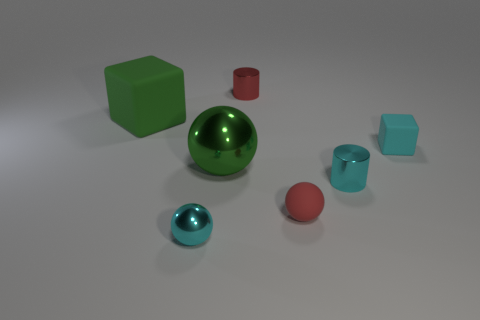Are there an equal number of small objects behind the big cube and cubes that are to the left of the large metal ball? Upon reviewing the objects in the image, it appears that there are two small objects behind the large green cube – a red cylinder and a small red sphere. To the left of the large metal ball, there is one cyan cube. So, there is not an equal number of small objects in the mentioned areas. 